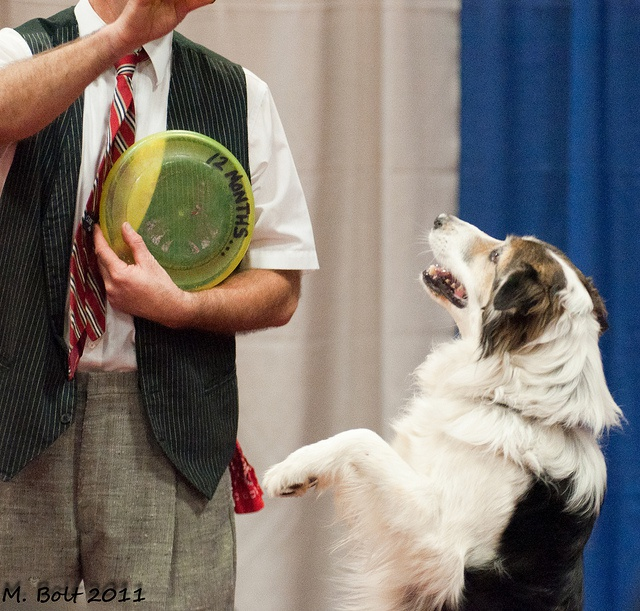Describe the objects in this image and their specific colors. I can see people in gray, black, darkgreen, and lightgray tones, dog in gray, ivory, black, lightgray, and tan tones, frisbee in gray, darkgreen, and olive tones, and tie in gray, maroon, black, and brown tones in this image. 